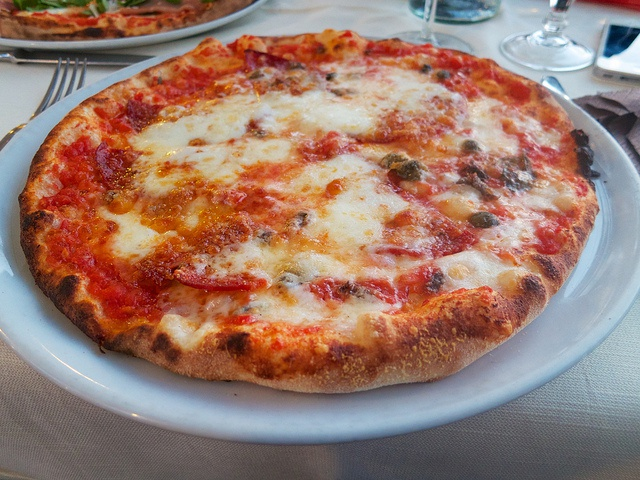Describe the objects in this image and their specific colors. I can see pizza in brown and tan tones, dining table in brown, gray, darkgray, and lightgray tones, wine glass in brown, lightblue, lightgray, and darkgray tones, cell phone in brown, white, darkgray, gray, and navy tones, and wine glass in brown, darkgray, and gray tones in this image. 